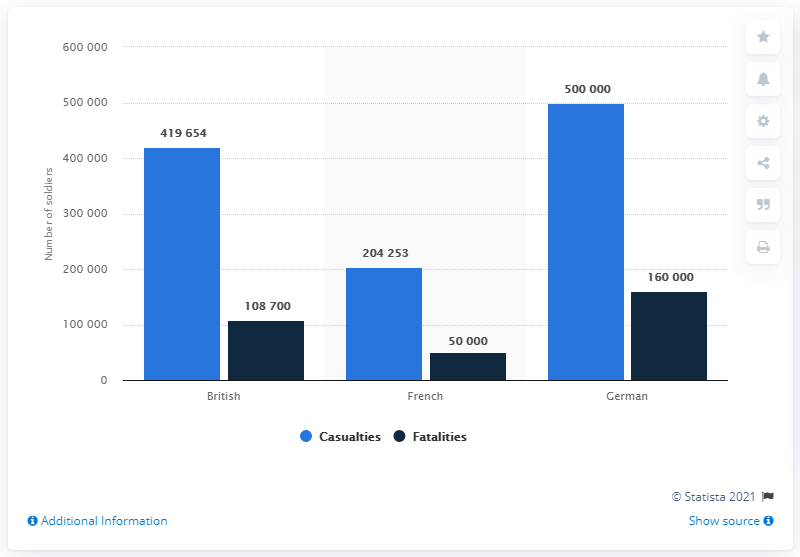Point out several critical features in this image. Germany has the highest casualties. The average of fatalities is 106,233. 